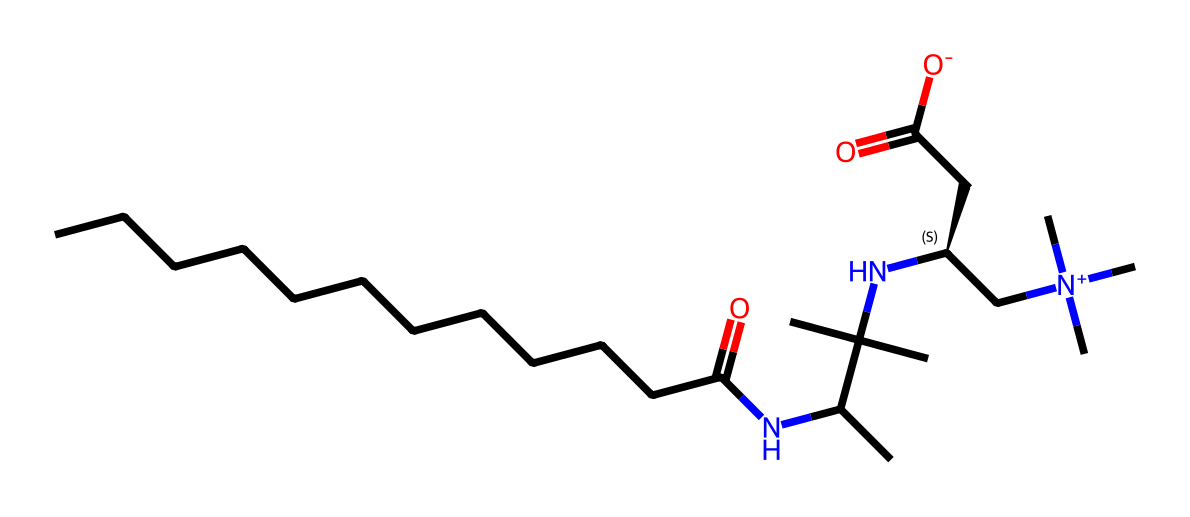How many carbon atoms are in the molecule? The SMILES representation shows the longest carbon chain consists of 12 carbon atoms in the linear part. Additionally, there are 3 more carbon atoms in the branches. Adding these together, there are 15 carbon atoms total.
Answer: 15 What functional group is indicated by "NC"? The "NC" in the SMILES indicates the presence of an amine functional group, where nitrogen is bonded to a carbon. This shows that the molecule contains an amine.
Answer: amine What type of surfactant is cocamidopropyl betaine? Cocamidopropyl betaine is categorized as a zwitterionic surfactant due to the presence of both positive and negative charges in the molecule, specifically corresponding to the ammonium (N+) and carboxylate (COO-) groups.
Answer: zwitterionic How many nitrogen atoms are present in the molecule? In the SMILES representation, there are four instances of 'N', indicating that there are 4 nitrogen atoms in total present in the molecule structure.
Answer: 4 What is the overall charge of cocamidopropyl betaine? Analyzing the structure, there is a positive charge on the quaternary ammonium group (N+) and a negative charge on the carboxylate (COO-), which balance each other out, resulting in a net charge of zero.
Answer: neutral Which part of this chemical structure contributes to its surfactant properties? The long hydrophobic carbon chain provides oil solubility and the hydrophilic head containing the zwitterionic characteristic contributes to its water solubility, allowing for surface activity.
Answer: hydrophobic chain and zwitterionic head 